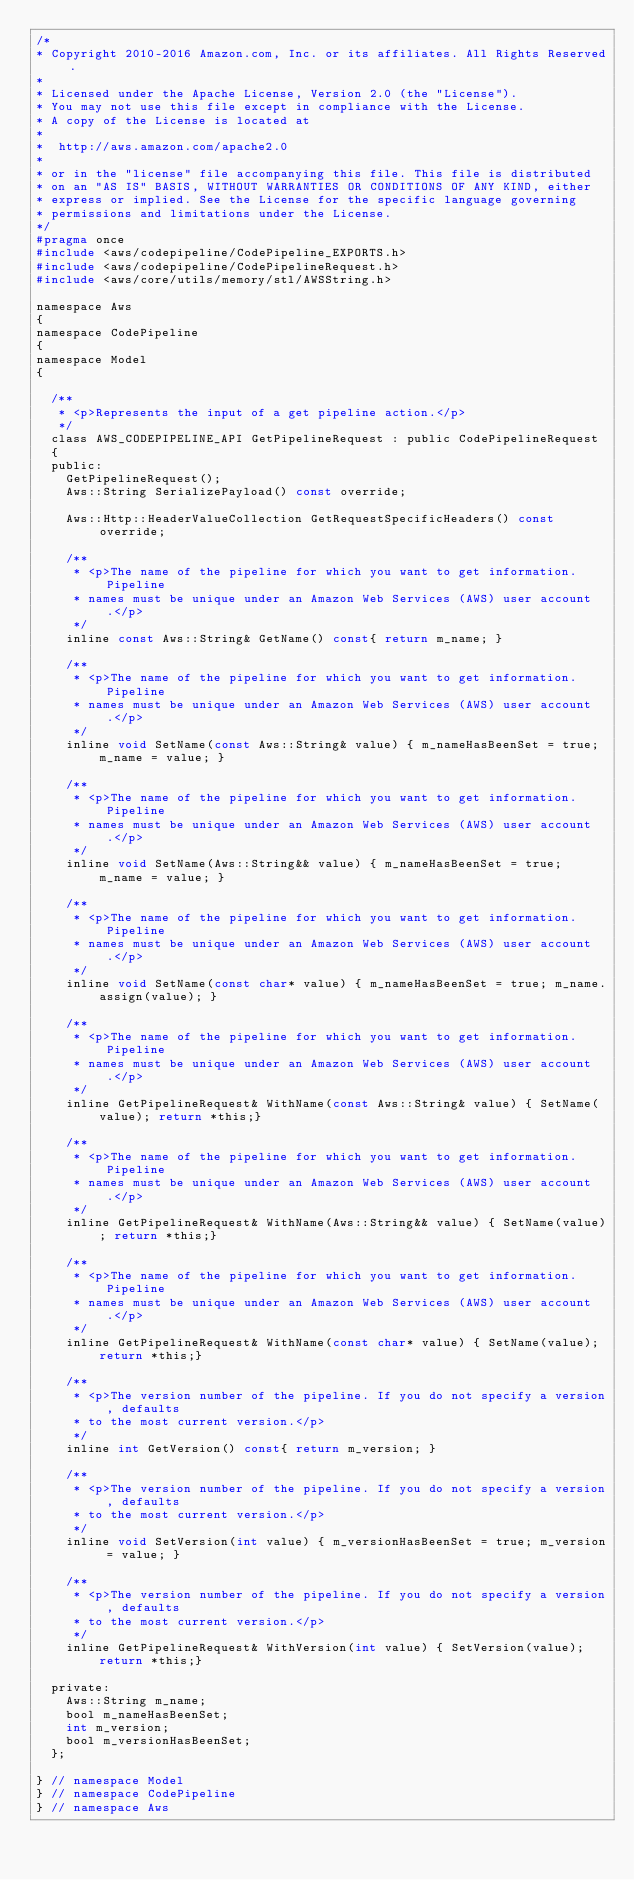Convert code to text. <code><loc_0><loc_0><loc_500><loc_500><_C_>/*
* Copyright 2010-2016 Amazon.com, Inc. or its affiliates. All Rights Reserved.
*
* Licensed under the Apache License, Version 2.0 (the "License").
* You may not use this file except in compliance with the License.
* A copy of the License is located at
*
*  http://aws.amazon.com/apache2.0
*
* or in the "license" file accompanying this file. This file is distributed
* on an "AS IS" BASIS, WITHOUT WARRANTIES OR CONDITIONS OF ANY KIND, either
* express or implied. See the License for the specific language governing
* permissions and limitations under the License.
*/
#pragma once
#include <aws/codepipeline/CodePipeline_EXPORTS.h>
#include <aws/codepipeline/CodePipelineRequest.h>
#include <aws/core/utils/memory/stl/AWSString.h>

namespace Aws
{
namespace CodePipeline
{
namespace Model
{

  /**
   * <p>Represents the input of a get pipeline action.</p>
   */
  class AWS_CODEPIPELINE_API GetPipelineRequest : public CodePipelineRequest
  {
  public:
    GetPipelineRequest();
    Aws::String SerializePayload() const override;

    Aws::Http::HeaderValueCollection GetRequestSpecificHeaders() const override;

    /**
     * <p>The name of the pipeline for which you want to get information. Pipeline
     * names must be unique under an Amazon Web Services (AWS) user account.</p>
     */
    inline const Aws::String& GetName() const{ return m_name; }

    /**
     * <p>The name of the pipeline for which you want to get information. Pipeline
     * names must be unique under an Amazon Web Services (AWS) user account.</p>
     */
    inline void SetName(const Aws::String& value) { m_nameHasBeenSet = true; m_name = value; }

    /**
     * <p>The name of the pipeline for which you want to get information. Pipeline
     * names must be unique under an Amazon Web Services (AWS) user account.</p>
     */
    inline void SetName(Aws::String&& value) { m_nameHasBeenSet = true; m_name = value; }

    /**
     * <p>The name of the pipeline for which you want to get information. Pipeline
     * names must be unique under an Amazon Web Services (AWS) user account.</p>
     */
    inline void SetName(const char* value) { m_nameHasBeenSet = true; m_name.assign(value); }

    /**
     * <p>The name of the pipeline for which you want to get information. Pipeline
     * names must be unique under an Amazon Web Services (AWS) user account.</p>
     */
    inline GetPipelineRequest& WithName(const Aws::String& value) { SetName(value); return *this;}

    /**
     * <p>The name of the pipeline for which you want to get information. Pipeline
     * names must be unique under an Amazon Web Services (AWS) user account.</p>
     */
    inline GetPipelineRequest& WithName(Aws::String&& value) { SetName(value); return *this;}

    /**
     * <p>The name of the pipeline for which you want to get information. Pipeline
     * names must be unique under an Amazon Web Services (AWS) user account.</p>
     */
    inline GetPipelineRequest& WithName(const char* value) { SetName(value); return *this;}

    /**
     * <p>The version number of the pipeline. If you do not specify a version, defaults
     * to the most current version.</p>
     */
    inline int GetVersion() const{ return m_version; }

    /**
     * <p>The version number of the pipeline. If you do not specify a version, defaults
     * to the most current version.</p>
     */
    inline void SetVersion(int value) { m_versionHasBeenSet = true; m_version = value; }

    /**
     * <p>The version number of the pipeline. If you do not specify a version, defaults
     * to the most current version.</p>
     */
    inline GetPipelineRequest& WithVersion(int value) { SetVersion(value); return *this;}

  private:
    Aws::String m_name;
    bool m_nameHasBeenSet;
    int m_version;
    bool m_versionHasBeenSet;
  };

} // namespace Model
} // namespace CodePipeline
} // namespace Aws
</code> 